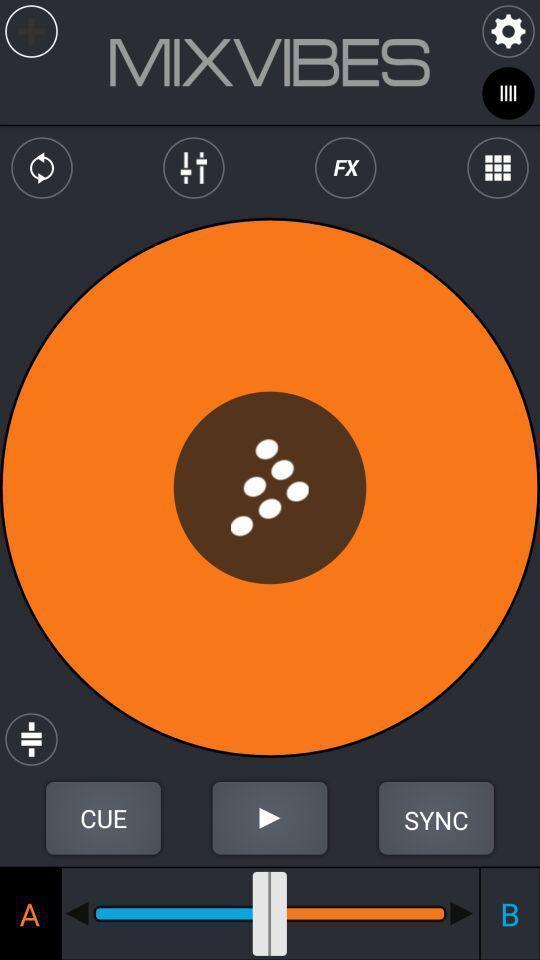Tell me about the visual elements in this screen capture. Various options for music player app. 